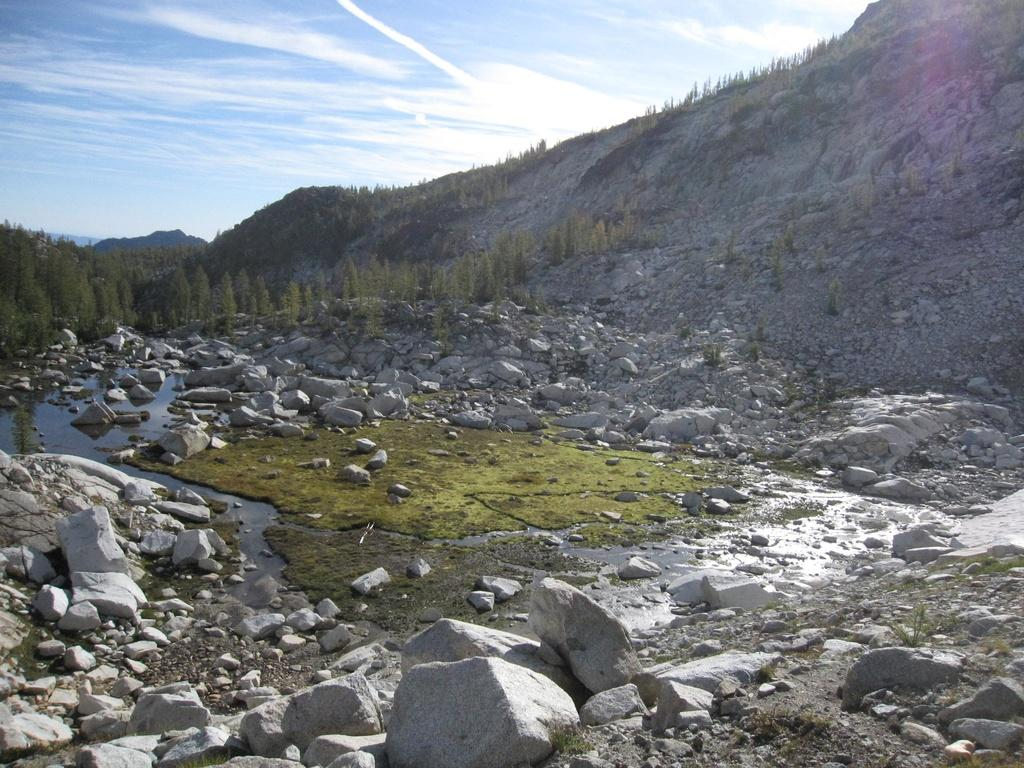What type of terrain is visible in the image? Ground, water, stones, huge rocks, grass, and trees are visible in the image. What natural features can be seen in the background? There is a mountain, more trees, and the sky visible in the background. What type of vegetation is present in the image? Grass and trees are present in the image. What type of crown is the king wearing in the image? There is no king or crown present in the image. What knowledge can be gained from the journey depicted in the image? There is no journey depicted in the image, so no knowledge can be gained from it. 